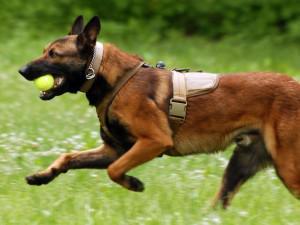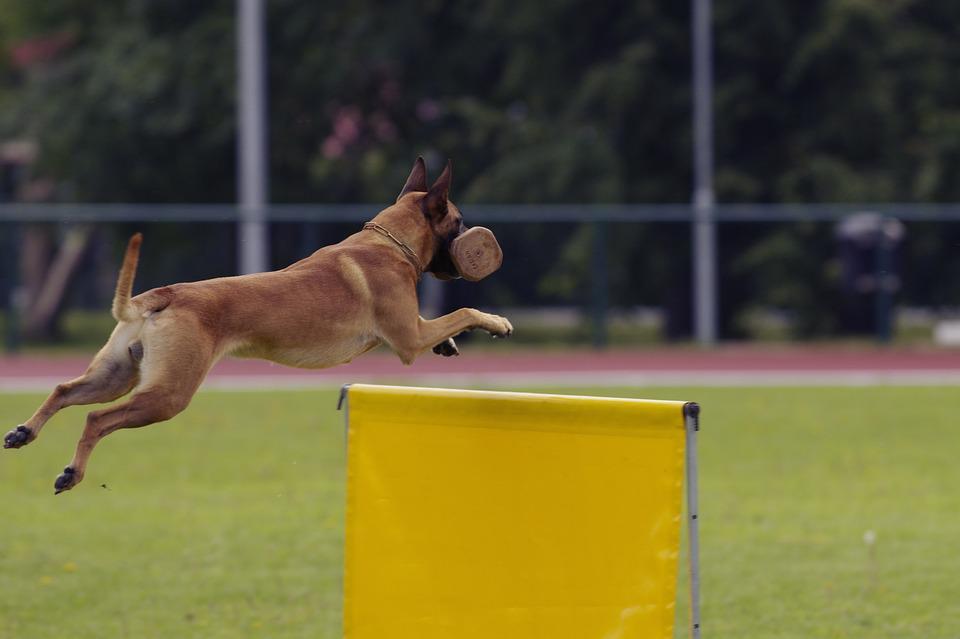The first image is the image on the left, the second image is the image on the right. Evaluate the accuracy of this statement regarding the images: "In at least one image, a dog is gripping a toy in its mouth.". Is it true? Answer yes or no. Yes. 